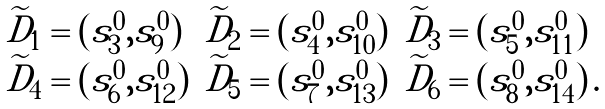<formula> <loc_0><loc_0><loc_500><loc_500>\begin{array} { l l l } \widetilde { D } _ { 1 } = ( s ^ { 0 } _ { 3 } , s ^ { 0 } _ { 9 } ) & \widetilde { D } _ { 2 } = ( s ^ { 0 } _ { 4 } , s ^ { 0 } _ { 1 0 } ) & \widetilde { D } _ { 3 } = ( s ^ { 0 } _ { 5 } , s ^ { 0 } _ { 1 1 } ) \\ \widetilde { D } _ { 4 } = ( s ^ { 0 } _ { 6 } , s ^ { 0 } _ { 1 2 } ) & \widetilde { D } _ { 5 } = ( s ^ { 0 } _ { 7 } , s ^ { 0 } _ { 1 3 } ) & \widetilde { D } _ { 6 } = ( s ^ { 0 } _ { 8 } , s ^ { 0 } _ { 1 4 } ) \, . \end{array}</formula> 